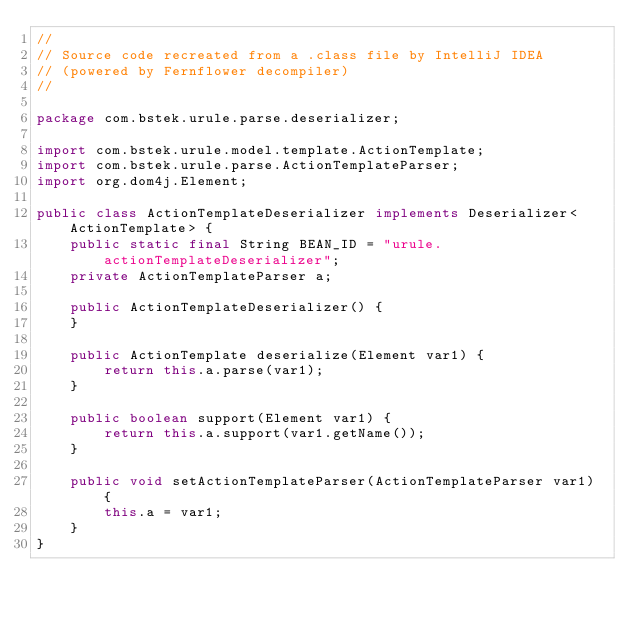<code> <loc_0><loc_0><loc_500><loc_500><_Java_>//
// Source code recreated from a .class file by IntelliJ IDEA
// (powered by Fernflower decompiler)
//

package com.bstek.urule.parse.deserializer;

import com.bstek.urule.model.template.ActionTemplate;
import com.bstek.urule.parse.ActionTemplateParser;
import org.dom4j.Element;

public class ActionTemplateDeserializer implements Deserializer<ActionTemplate> {
    public static final String BEAN_ID = "urule.actionTemplateDeserializer";
    private ActionTemplateParser a;

    public ActionTemplateDeserializer() {
    }

    public ActionTemplate deserialize(Element var1) {
        return this.a.parse(var1);
    }

    public boolean support(Element var1) {
        return this.a.support(var1.getName());
    }

    public void setActionTemplateParser(ActionTemplateParser var1) {
        this.a = var1;
    }
}
</code> 